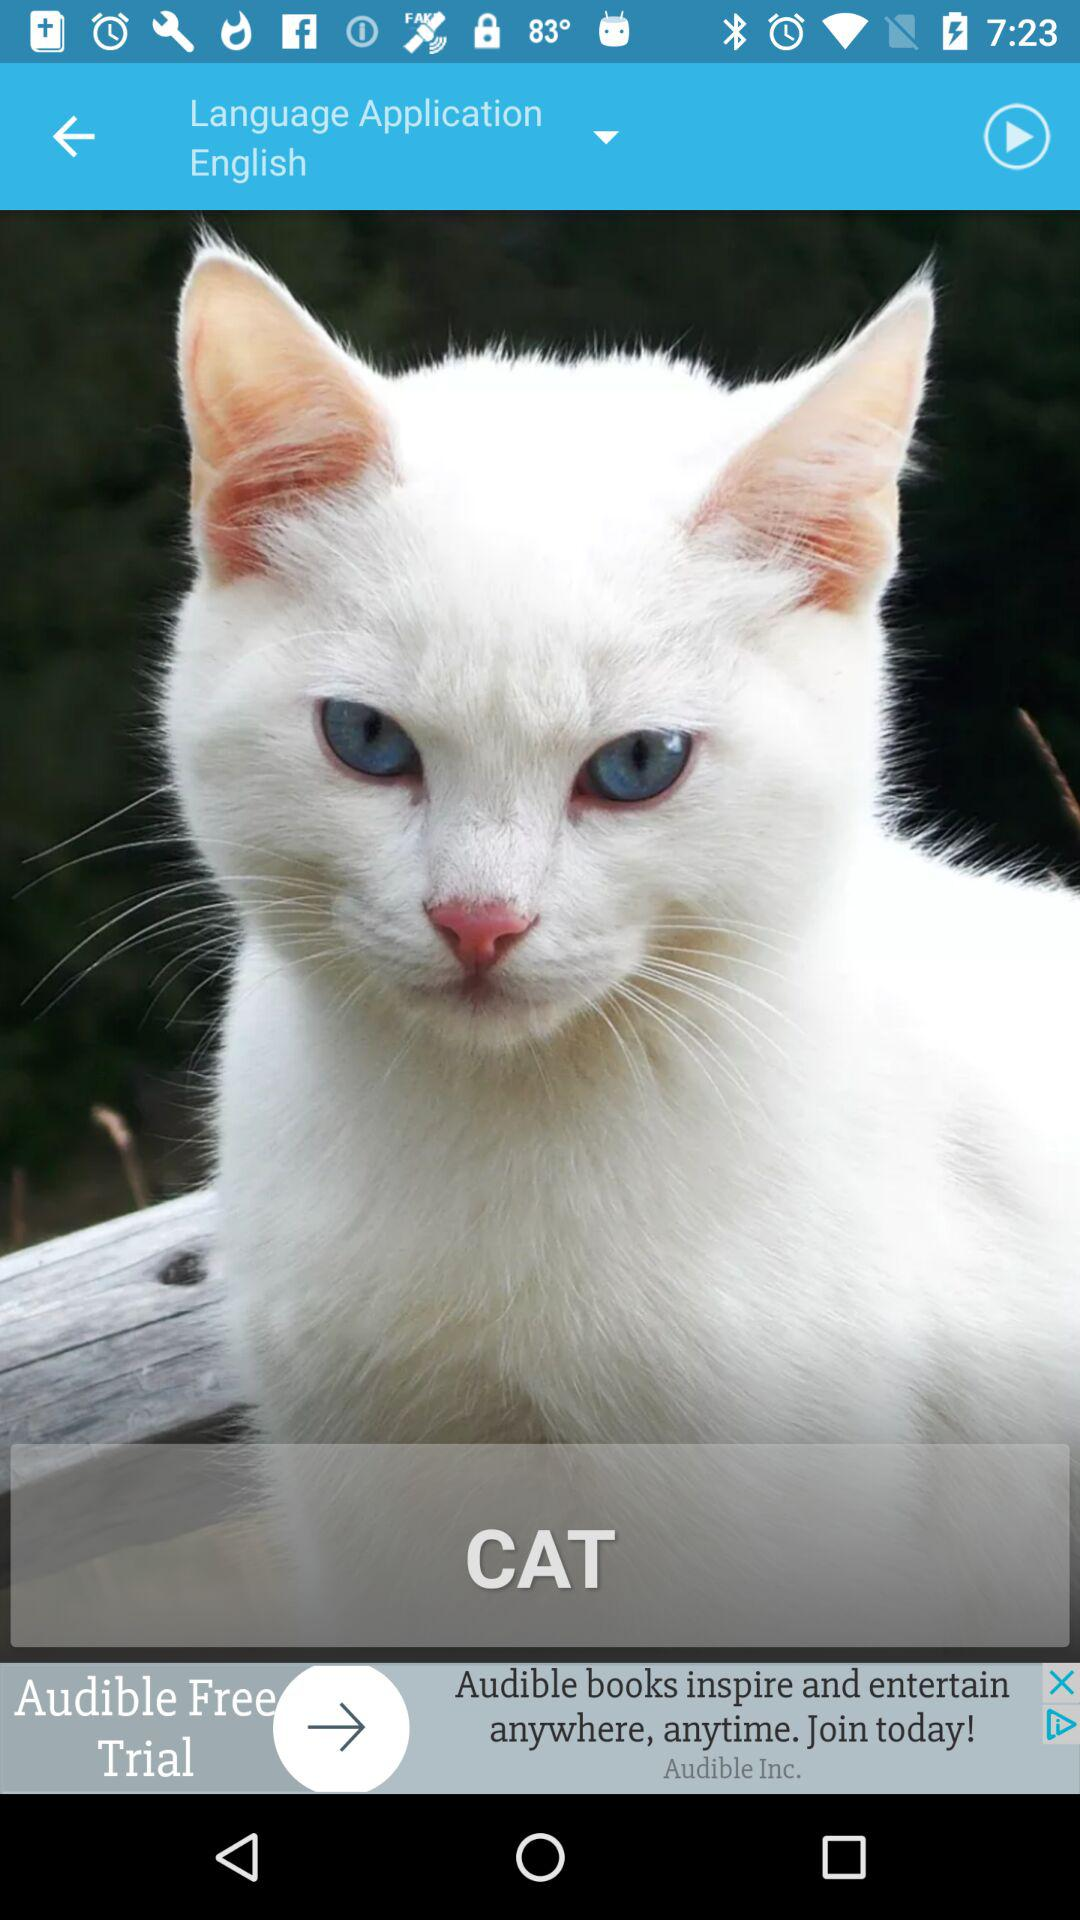Which language option is selected? The selected option is "English". 